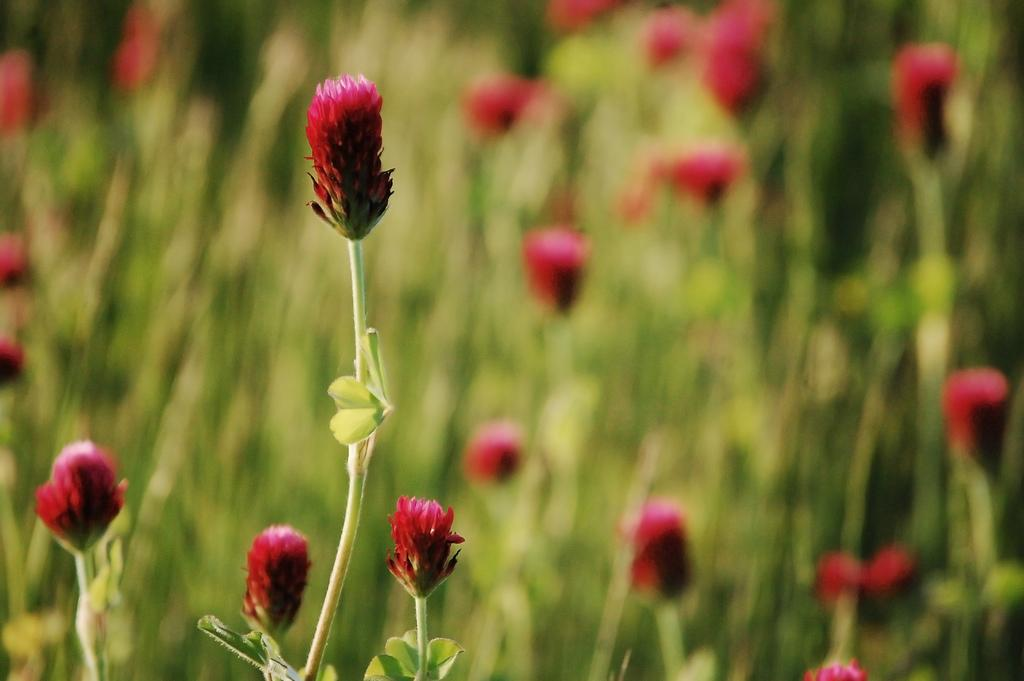What type of plants can be seen in the image? There are flowers in the image. What parts of the plants are visible? There are stems and leaves in the image. How would you describe the background of the image? The background of the image is blurry. What type of wheel is attached to the flowers in the image? There is no wheel present in the image; it features flowers, stems, and leaves. What title can be seen on the flowers in the image? There is no title present in the image; it features flowers, stems, and leaves. 